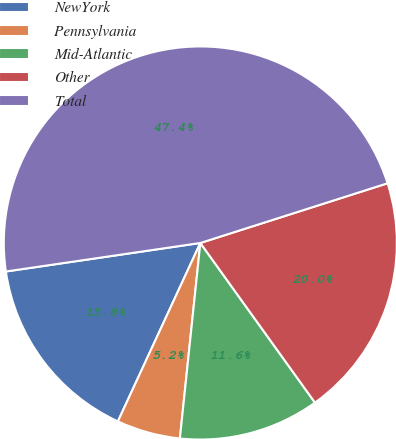Convert chart. <chart><loc_0><loc_0><loc_500><loc_500><pie_chart><fcel>NewYork<fcel>Pennsylvania<fcel>Mid-Atlantic<fcel>Other<fcel>Total<nl><fcel>15.79%<fcel>5.23%<fcel>11.57%<fcel>20.0%<fcel>47.4%<nl></chart> 